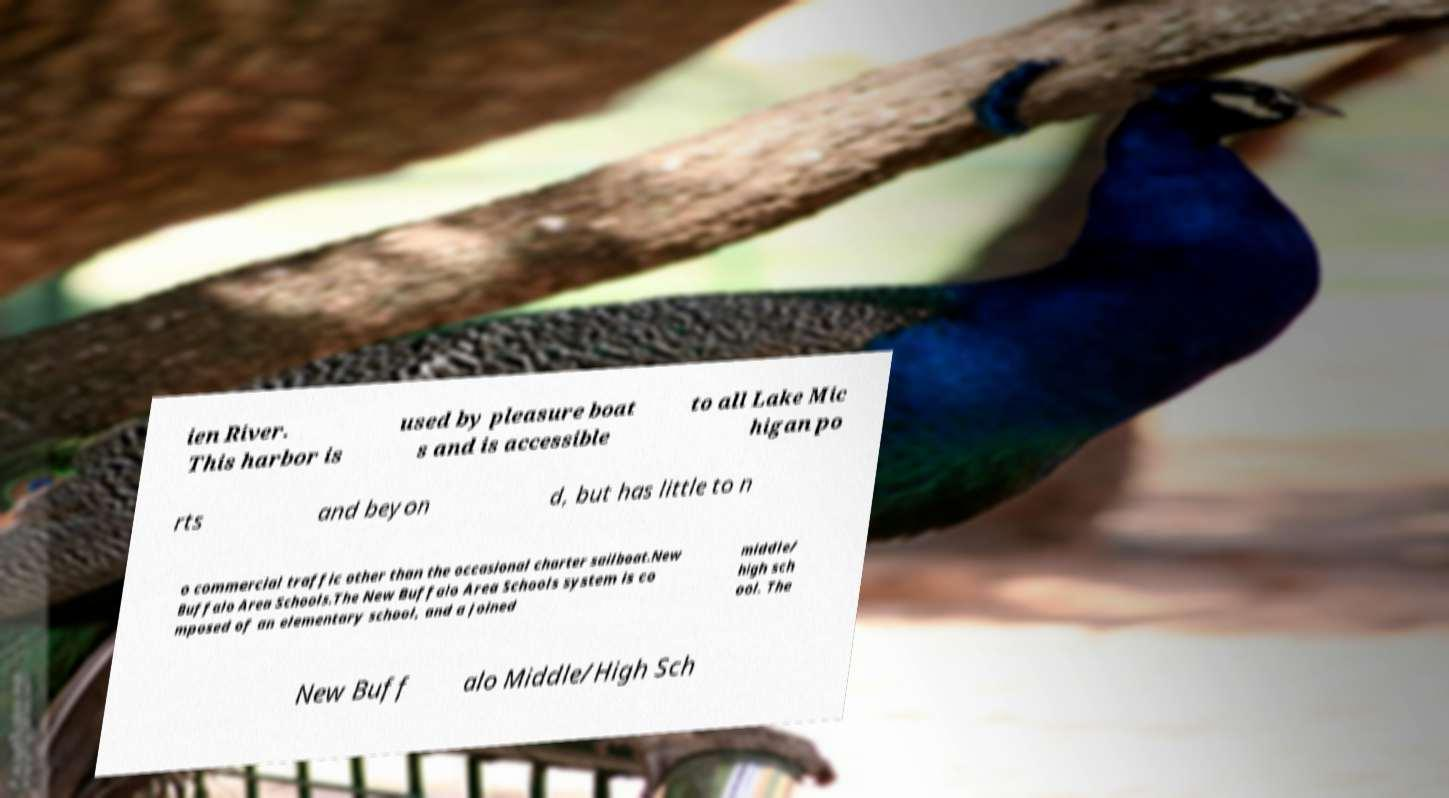For documentation purposes, I need the text within this image transcribed. Could you provide that? ien River. This harbor is used by pleasure boat s and is accessible to all Lake Mic higan po rts and beyon d, but has little to n o commercial traffic other than the occasional charter sailboat.New Buffalo Area Schools.The New Buffalo Area Schools system is co mposed of an elementary school, and a joined middle/ high sch ool. The New Buff alo Middle/High Sch 